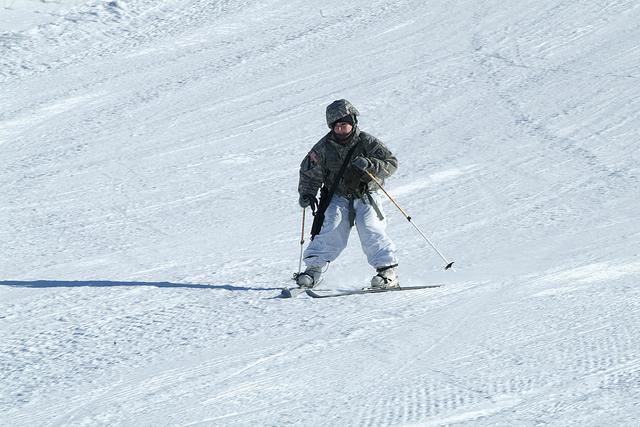What is covering the ground?
Keep it brief. Snow. What is this person doing?
Quick response, please. Skiing. What is the person holding?
Write a very short answer. Ski poles. 